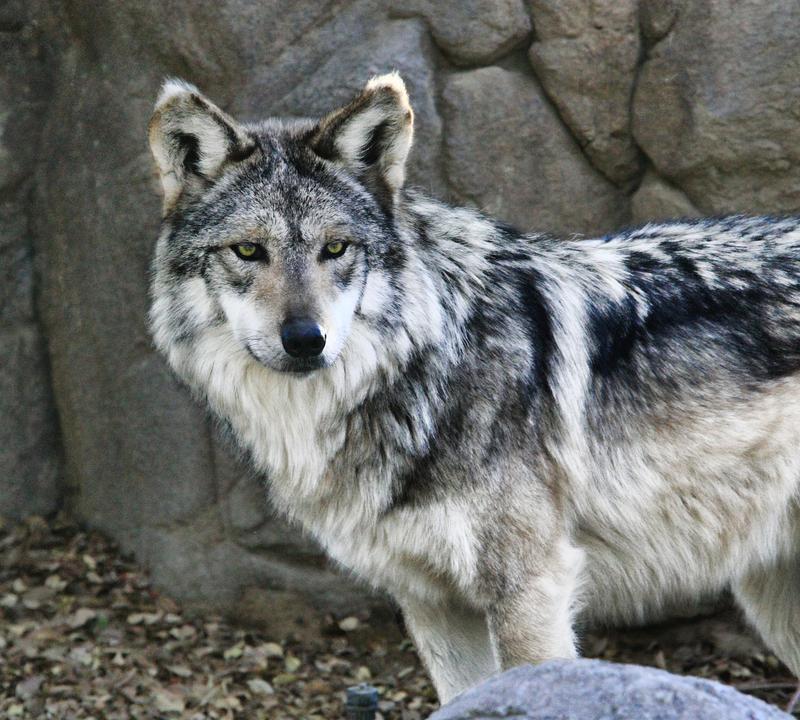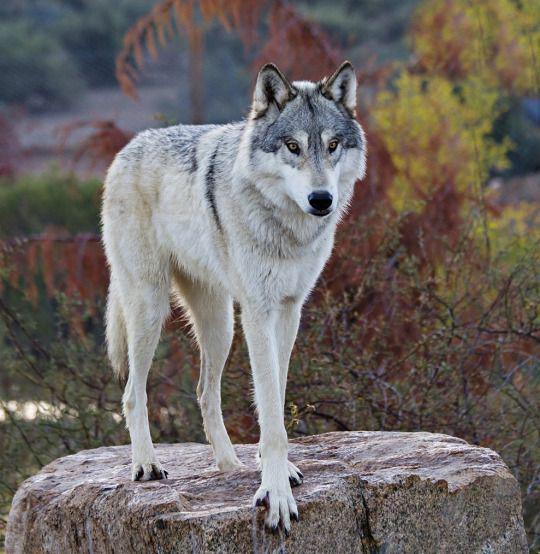The first image is the image on the left, the second image is the image on the right. Assess this claim about the two images: "There are at most 3 wolves.". Correct or not? Answer yes or no. Yes. The first image is the image on the left, the second image is the image on the right. Evaluate the accuracy of this statement regarding the images: "You can clearly see there are more than three wolves or dogs.". Is it true? Answer yes or no. No. 